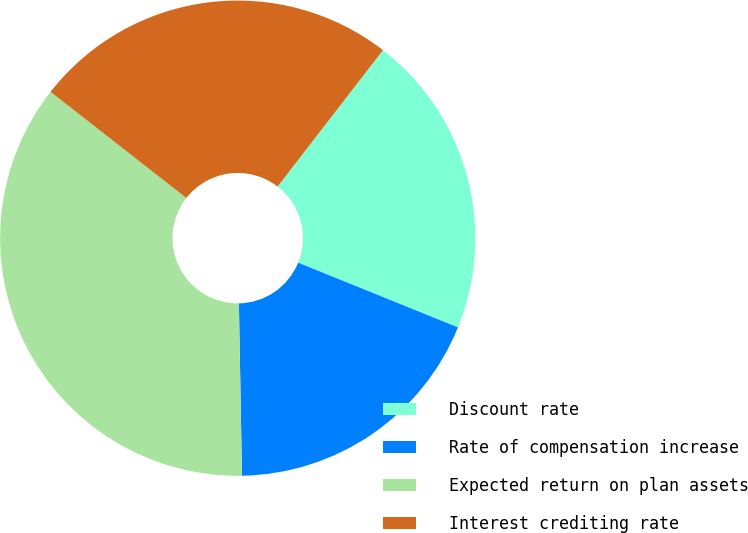<chart> <loc_0><loc_0><loc_500><loc_500><pie_chart><fcel>Discount rate<fcel>Rate of compensation increase<fcel>Expected return on plan assets<fcel>Interest crediting rate<nl><fcel>20.66%<fcel>18.59%<fcel>35.85%<fcel>24.91%<nl></chart> 